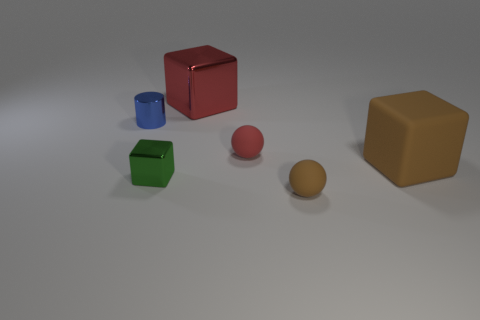Subtract all metal blocks. How many blocks are left? 1 Subtract 2 balls. How many balls are left? 0 Add 1 yellow cubes. How many objects exist? 7 Subtract all cylinders. How many objects are left? 5 Subtract all red spheres. How many spheres are left? 1 Subtract 0 purple cylinders. How many objects are left? 6 Subtract all cyan cubes. Subtract all cyan cylinders. How many cubes are left? 3 Subtract all red cubes. How many brown balls are left? 1 Subtract all red things. Subtract all small cyan matte blocks. How many objects are left? 4 Add 1 small rubber objects. How many small rubber objects are left? 3 